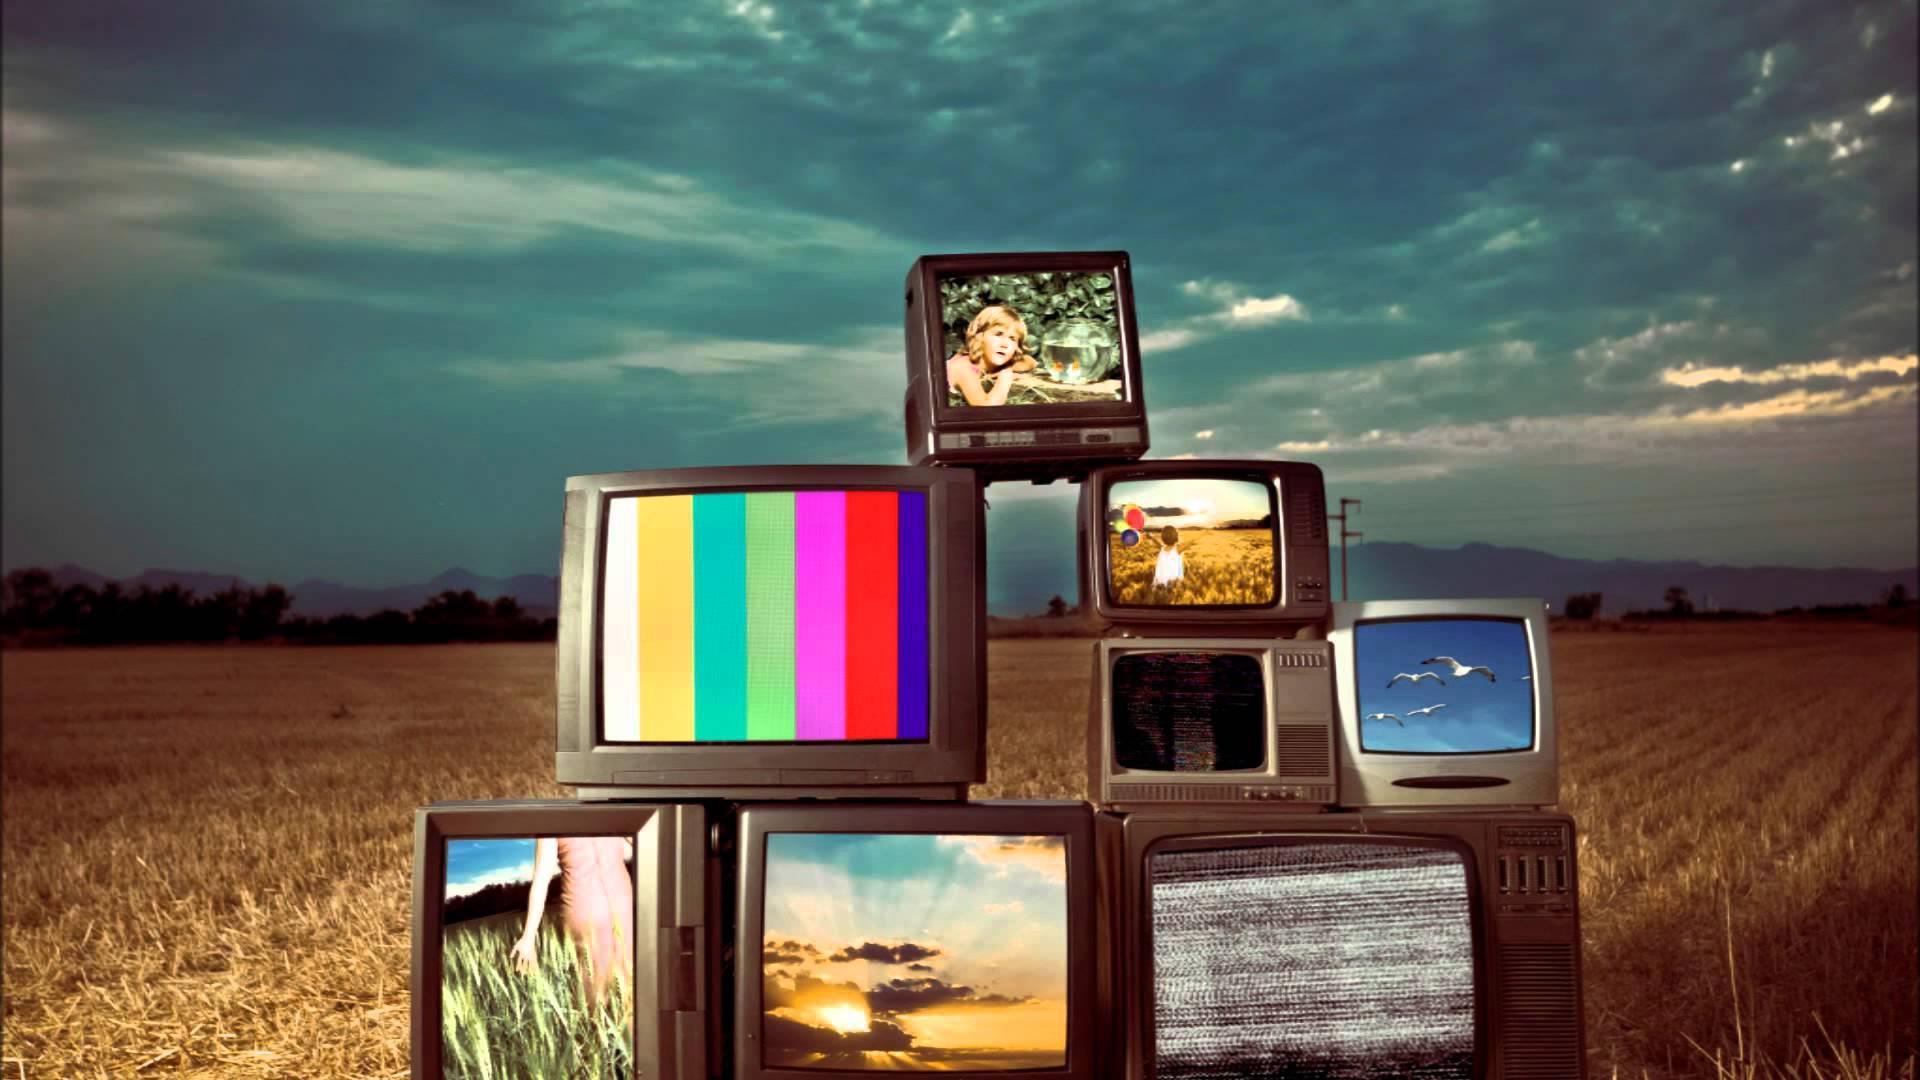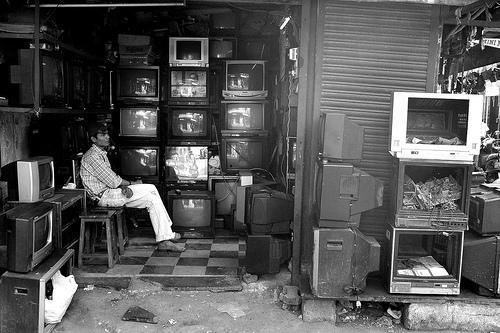The first image is the image on the left, the second image is the image on the right. Given the left and right images, does the statement "An image includes a vertical stack of four TVs, stacked from the biggest on the bottom to the smallest on top." hold true? Answer yes or no. No. The first image is the image on the left, the second image is the image on the right. For the images displayed, is the sentence "One image includes only a single television set." factually correct? Answer yes or no. No. 